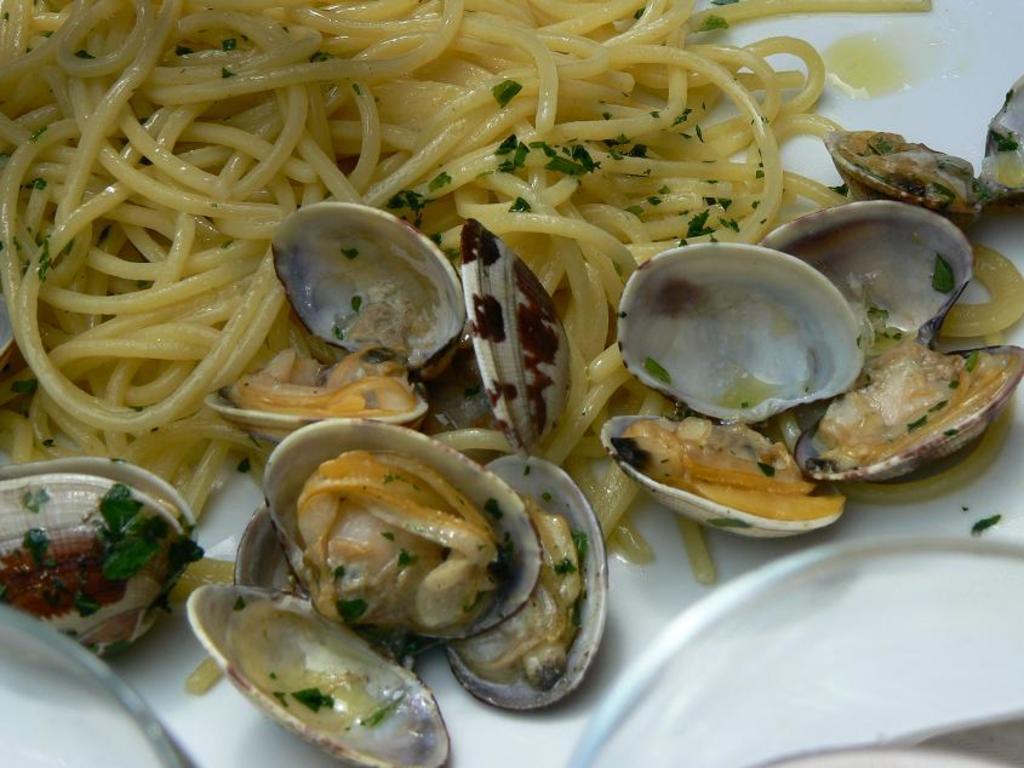In one or two sentences, can you explain what this image depicts? In this picture there is a plate in the center of the image, which contains noodles in it and there are shells in it. 